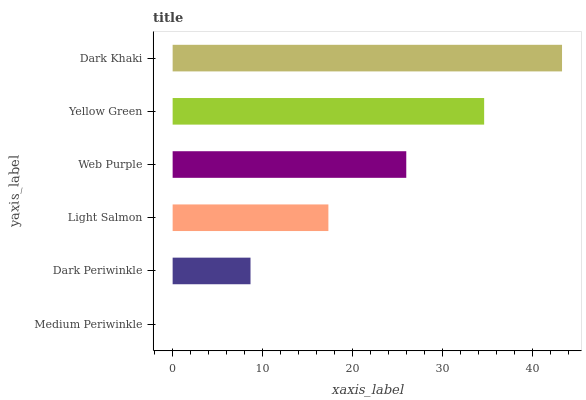Is Medium Periwinkle the minimum?
Answer yes or no. Yes. Is Dark Khaki the maximum?
Answer yes or no. Yes. Is Dark Periwinkle the minimum?
Answer yes or no. No. Is Dark Periwinkle the maximum?
Answer yes or no. No. Is Dark Periwinkle greater than Medium Periwinkle?
Answer yes or no. Yes. Is Medium Periwinkle less than Dark Periwinkle?
Answer yes or no. Yes. Is Medium Periwinkle greater than Dark Periwinkle?
Answer yes or no. No. Is Dark Periwinkle less than Medium Periwinkle?
Answer yes or no. No. Is Web Purple the high median?
Answer yes or no. Yes. Is Light Salmon the low median?
Answer yes or no. Yes. Is Dark Khaki the high median?
Answer yes or no. No. Is Dark Khaki the low median?
Answer yes or no. No. 